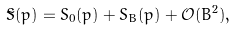<formula> <loc_0><loc_0><loc_500><loc_500>\tilde { S } ( p ) = S _ { 0 } ( p ) + S _ { B } ( p ) + \mathcal { O } ( B ^ { 2 } ) ,</formula> 